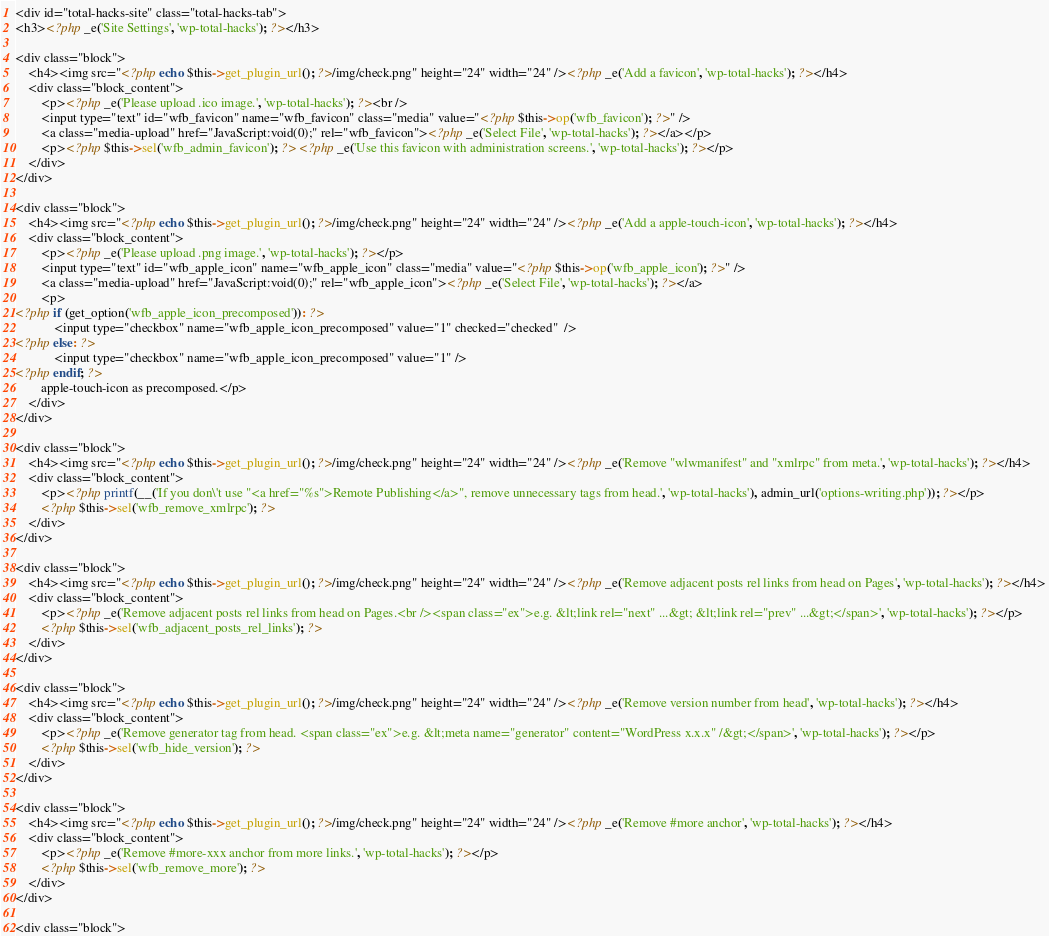Convert code to text. <code><loc_0><loc_0><loc_500><loc_500><_PHP_><div id="total-hacks-site" class="total-hacks-tab">
<h3><?php _e('Site Settings', 'wp-total-hacks'); ?></h3>

<div class="block">
    <h4><img src="<?php echo $this->get_plugin_url(); ?>/img/check.png" height="24" width="24" /><?php _e('Add a favicon', 'wp-total-hacks'); ?></h4>
    <div class="block_content">
        <p><?php _e('Please upload .ico image.', 'wp-total-hacks'); ?><br />
        <input type="text" id="wfb_favicon" name="wfb_favicon" class="media" value="<?php $this->op('wfb_favicon'); ?>" />
        <a class="media-upload" href="JavaScript:void(0);" rel="wfb_favicon"><?php _e('Select File', 'wp-total-hacks'); ?></a></p>
        <p><?php $this->sel('wfb_admin_favicon'); ?> <?php _e('Use this favicon with administration screens.', 'wp-total-hacks'); ?></p>
    </div>
</div>

<div class="block">
    <h4><img src="<?php echo $this->get_plugin_url(); ?>/img/check.png" height="24" width="24" /><?php _e('Add a apple-touch-icon', 'wp-total-hacks'); ?></h4>
    <div class="block_content">
        <p><?php _e('Please upload .png image.', 'wp-total-hacks'); ?></p>
        <input type="text" id="wfb_apple_icon" name="wfb_apple_icon" class="media" value="<?php $this->op('wfb_apple_icon'); ?>" />
        <a class="media-upload" href="JavaScript:void(0);" rel="wfb_apple_icon"><?php _e('Select File', 'wp-total-hacks'); ?></a>
        <p>
<?php if (get_option('wfb_apple_icon_precomposed')): ?>
            <input type="checkbox" name="wfb_apple_icon_precomposed" value="1" checked="checked"  />
<?php else: ?>
            <input type="checkbox" name="wfb_apple_icon_precomposed" value="1" />
<?php endif; ?>
        apple-touch-icon as precomposed.</p>
    </div>
</div>

<div class="block">
    <h4><img src="<?php echo $this->get_plugin_url(); ?>/img/check.png" height="24" width="24" /><?php _e('Remove "wlwmanifest" and "xmlrpc" from meta.', 'wp-total-hacks'); ?></h4>
    <div class="block_content">
        <p><?php printf(__('If you don\'t use "<a href="%s">Remote Publishing</a>", remove unnecessary tags from head.', 'wp-total-hacks'), admin_url('options-writing.php')); ?></p>
        <?php $this->sel('wfb_remove_xmlrpc'); ?>
    </div>
</div>

<div class="block">
    <h4><img src="<?php echo $this->get_plugin_url(); ?>/img/check.png" height="24" width="24" /><?php _e('Remove adjacent posts rel links from head on Pages', 'wp-total-hacks'); ?></h4>
    <div class="block_content">
        <p><?php _e('Remove adjacent posts rel links from head on Pages.<br /><span class="ex">e.g. &lt;link rel="next" ...&gt; &lt;link rel="prev" ...&gt;</span>', 'wp-total-hacks'); ?></p>
        <?php $this->sel('wfb_adjacent_posts_rel_links'); ?>
    </div>
</div>

<div class="block">
    <h4><img src="<?php echo $this->get_plugin_url(); ?>/img/check.png" height="24" width="24" /><?php _e('Remove version number from head', 'wp-total-hacks'); ?></h4>
    <div class="block_content">
        <p><?php _e('Remove generator tag from head. <span class="ex">e.g. &lt;meta name="generator" content="WordPress x.x.x" /&gt;</span>', 'wp-total-hacks'); ?></p>
        <?php $this->sel('wfb_hide_version'); ?>
    </div>
</div>

<div class="block">
    <h4><img src="<?php echo $this->get_plugin_url(); ?>/img/check.png" height="24" width="24" /><?php _e('Remove #more anchor', 'wp-total-hacks'); ?></h4>
    <div class="block_content">
        <p><?php _e('Remove #more-xxx anchor from more links.', 'wp-total-hacks'); ?></p>
        <?php $this->sel('wfb_remove_more'); ?>
    </div>
</div>

<div class="block"></code> 